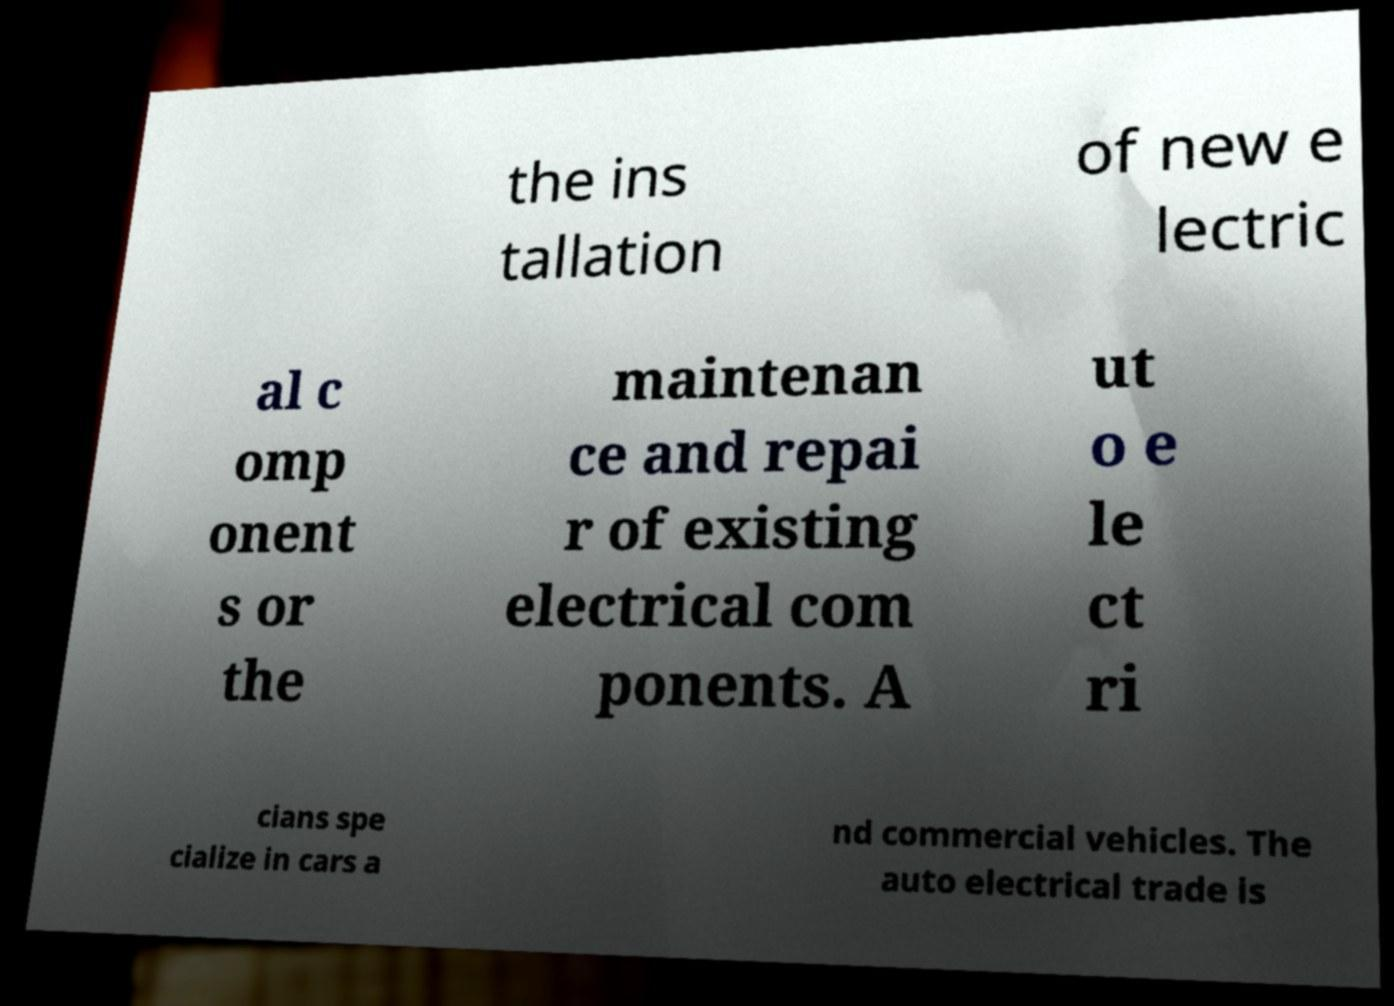Could you extract and type out the text from this image? the ins tallation of new e lectric al c omp onent s or the maintenan ce and repai r of existing electrical com ponents. A ut o e le ct ri cians spe cialize in cars a nd commercial vehicles. The auto electrical trade is 